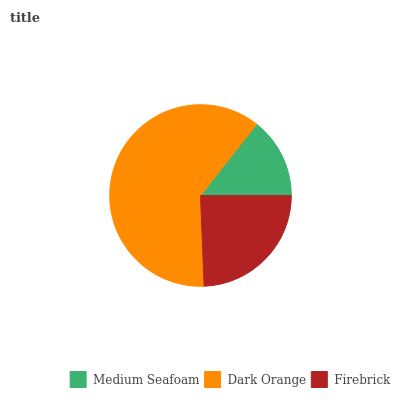Is Medium Seafoam the minimum?
Answer yes or no. Yes. Is Dark Orange the maximum?
Answer yes or no. Yes. Is Firebrick the minimum?
Answer yes or no. No. Is Firebrick the maximum?
Answer yes or no. No. Is Dark Orange greater than Firebrick?
Answer yes or no. Yes. Is Firebrick less than Dark Orange?
Answer yes or no. Yes. Is Firebrick greater than Dark Orange?
Answer yes or no. No. Is Dark Orange less than Firebrick?
Answer yes or no. No. Is Firebrick the high median?
Answer yes or no. Yes. Is Firebrick the low median?
Answer yes or no. Yes. Is Medium Seafoam the high median?
Answer yes or no. No. Is Dark Orange the low median?
Answer yes or no. No. 